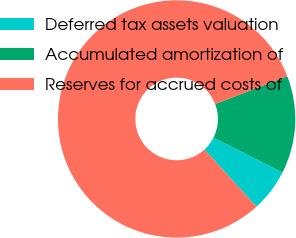<chart> <loc_0><loc_0><loc_500><loc_500><pie_chart><fcel>Deferred tax assets valuation<fcel>Accumulated amortization of<fcel>Reserves for accrued costs of<nl><fcel>5.8%<fcel>13.31%<fcel>80.88%<nl></chart> 